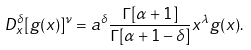<formula> <loc_0><loc_0><loc_500><loc_500>D _ { x } ^ { \delta } [ g ( x ) ] ^ { \nu } = a ^ { \delta } \frac { \Gamma [ \alpha + 1 ] } { \Gamma [ \alpha + 1 - \delta ] } x ^ { \lambda } g ( x ) .</formula> 